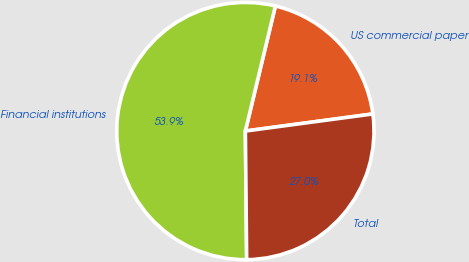<chart> <loc_0><loc_0><loc_500><loc_500><pie_chart><fcel>US commercial paper<fcel>Financial institutions<fcel>Total<nl><fcel>19.13%<fcel>53.91%<fcel>26.96%<nl></chart> 